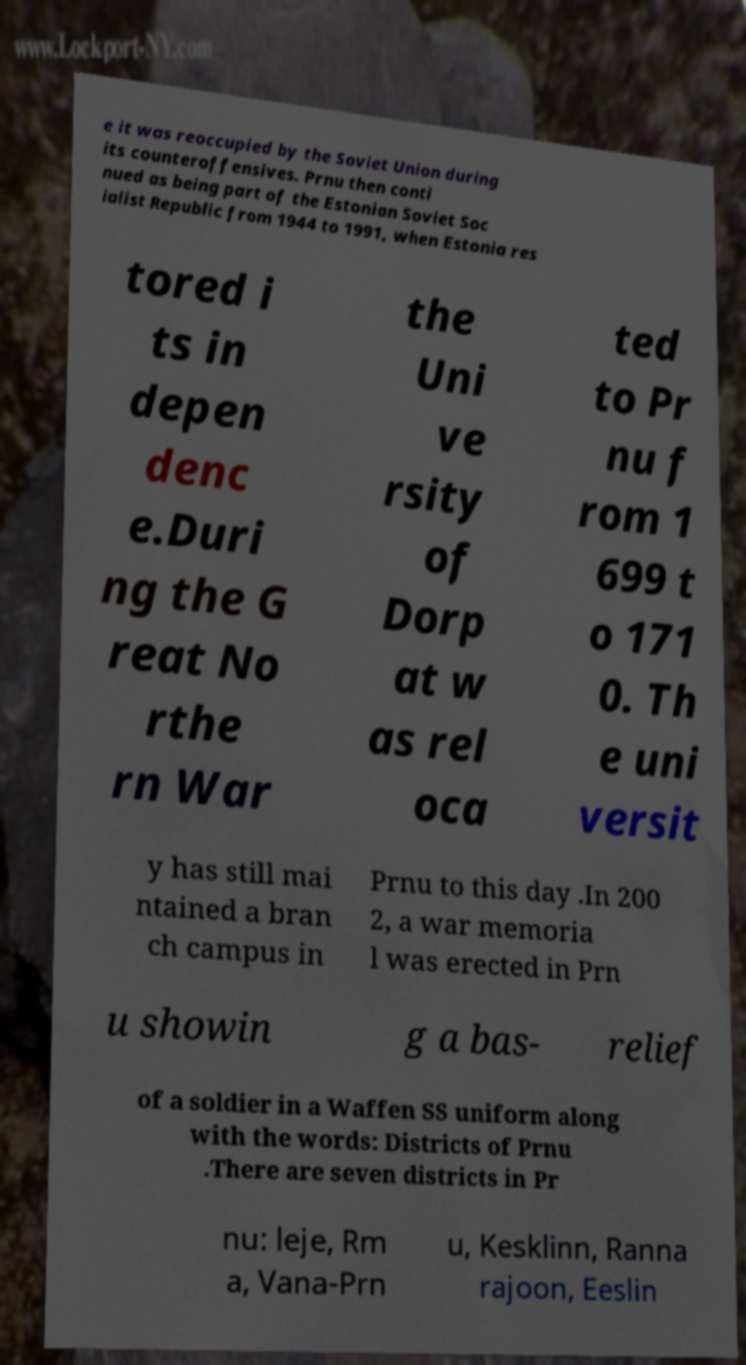Please read and relay the text visible in this image. What does it say? e it was reoccupied by the Soviet Union during its counteroffensives. Prnu then conti nued as being part of the Estonian Soviet Soc ialist Republic from 1944 to 1991, when Estonia res tored i ts in depen denc e.Duri ng the G reat No rthe rn War the Uni ve rsity of Dorp at w as rel oca ted to Pr nu f rom 1 699 t o 171 0. Th e uni versit y has still mai ntained a bran ch campus in Prnu to this day .In 200 2, a war memoria l was erected in Prn u showin g a bas- relief of a soldier in a Waffen SS uniform along with the words: Districts of Prnu .There are seven districts in Pr nu: leje, Rm a, Vana-Prn u, Kesklinn, Ranna rajoon, Eeslin 